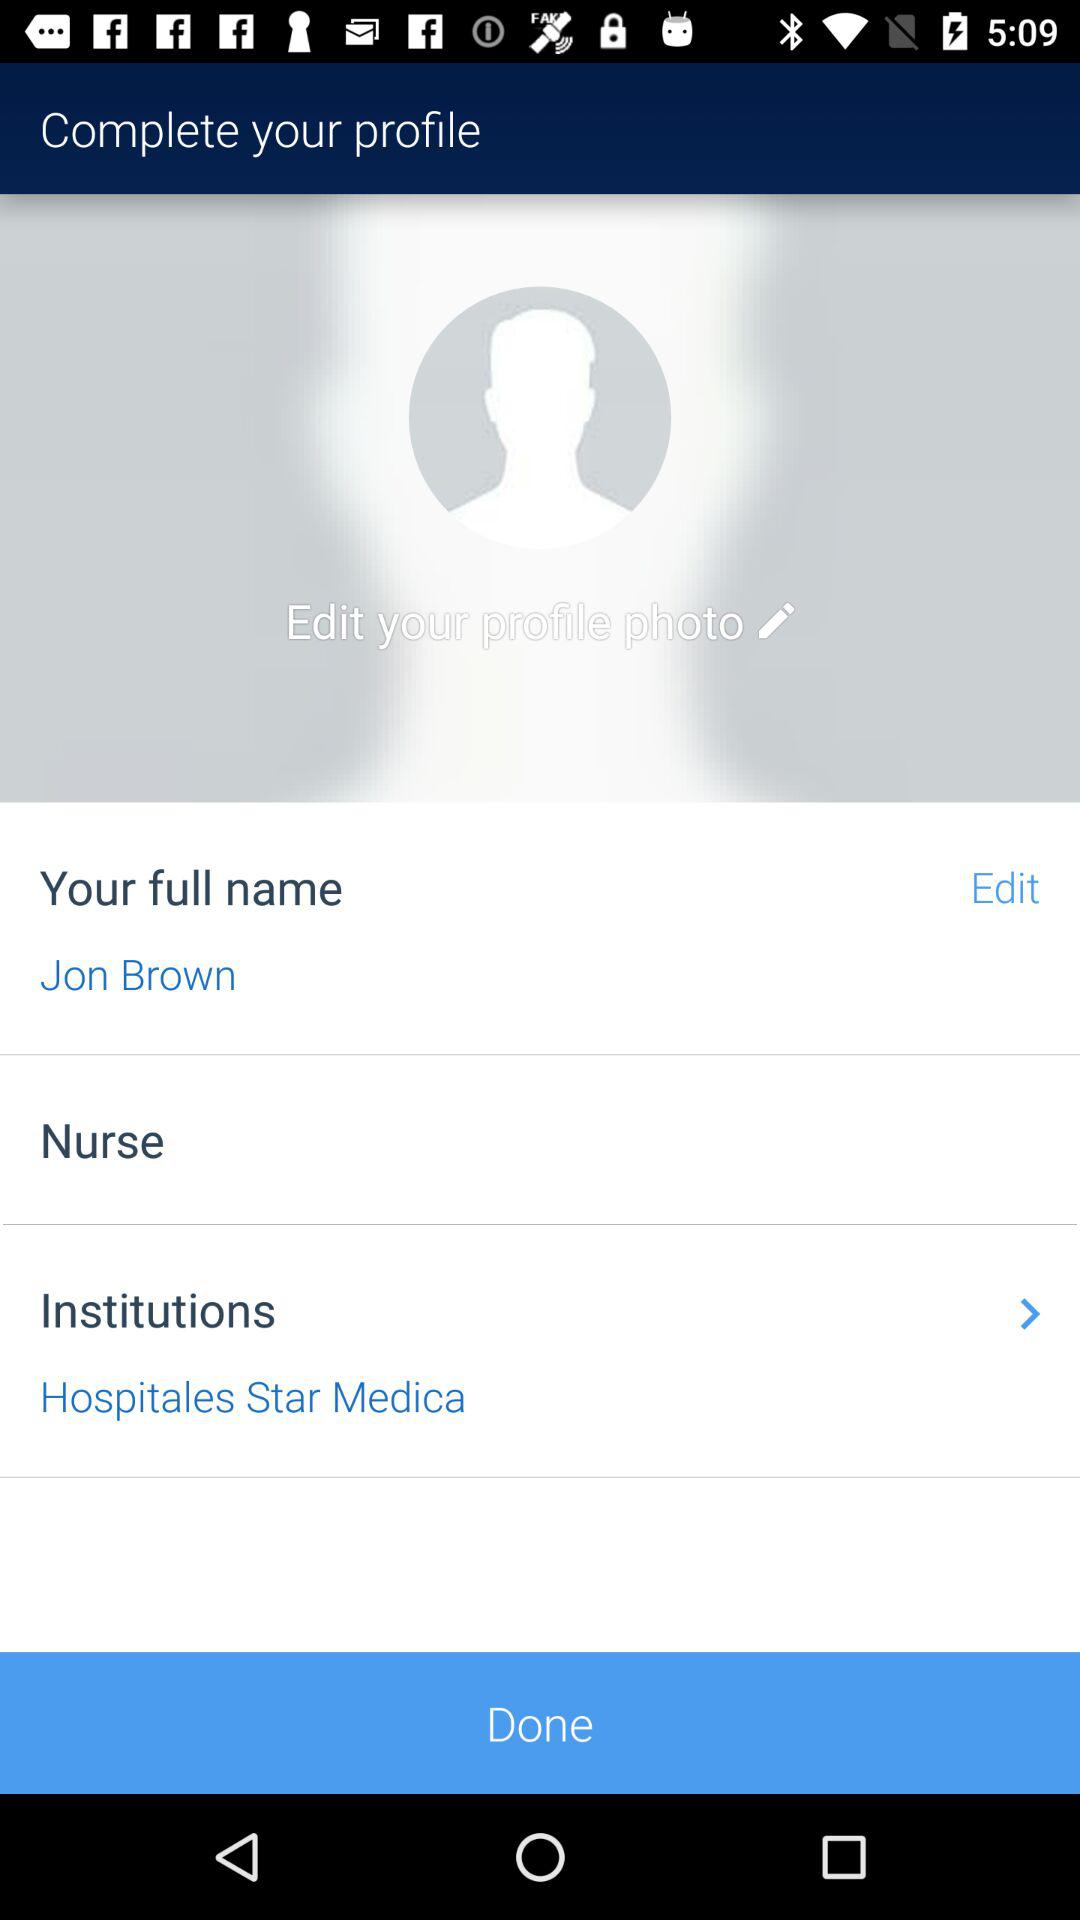What is the profession of user? The profession of the user is a nurse. 